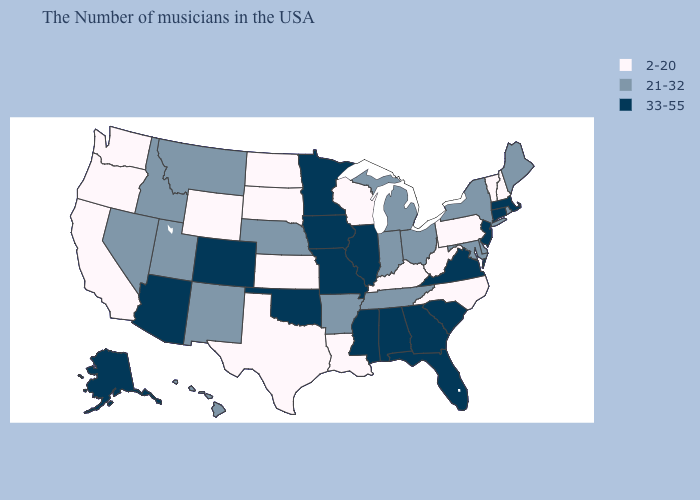What is the value of Alaska?
Quick response, please. 33-55. Does New York have a higher value than Oregon?
Keep it brief. Yes. Name the states that have a value in the range 2-20?
Be succinct. New Hampshire, Vermont, Pennsylvania, North Carolina, West Virginia, Kentucky, Wisconsin, Louisiana, Kansas, Texas, South Dakota, North Dakota, Wyoming, California, Washington, Oregon. Does Rhode Island have the same value as Maine?
Keep it brief. Yes. Name the states that have a value in the range 2-20?
Concise answer only. New Hampshire, Vermont, Pennsylvania, North Carolina, West Virginia, Kentucky, Wisconsin, Louisiana, Kansas, Texas, South Dakota, North Dakota, Wyoming, California, Washington, Oregon. Which states have the lowest value in the USA?
Be succinct. New Hampshire, Vermont, Pennsylvania, North Carolina, West Virginia, Kentucky, Wisconsin, Louisiana, Kansas, Texas, South Dakota, North Dakota, Wyoming, California, Washington, Oregon. What is the highest value in states that border Maryland?
Give a very brief answer. 33-55. What is the value of Michigan?
Quick response, please. 21-32. What is the highest value in states that border Massachusetts?
Quick response, please. 33-55. What is the value of Michigan?
Give a very brief answer. 21-32. Which states hav the highest value in the West?
Give a very brief answer. Colorado, Arizona, Alaska. Name the states that have a value in the range 33-55?
Quick response, please. Massachusetts, Connecticut, New Jersey, Virginia, South Carolina, Florida, Georgia, Alabama, Illinois, Mississippi, Missouri, Minnesota, Iowa, Oklahoma, Colorado, Arizona, Alaska. Does New Hampshire have the highest value in the Northeast?
Concise answer only. No. Which states have the lowest value in the Northeast?
Write a very short answer. New Hampshire, Vermont, Pennsylvania. What is the lowest value in the MidWest?
Quick response, please. 2-20. 